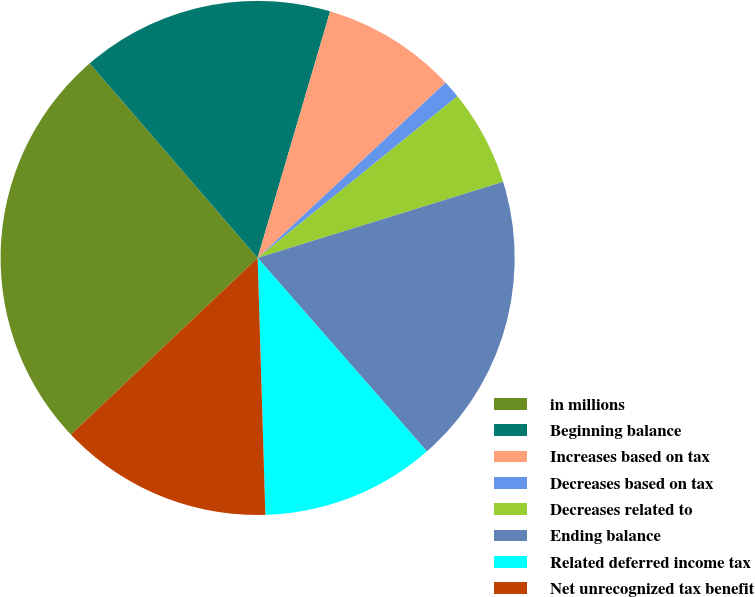Convert chart. <chart><loc_0><loc_0><loc_500><loc_500><pie_chart><fcel>in millions<fcel>Beginning balance<fcel>Increases based on tax<fcel>Decreases based on tax<fcel>Decreases related to<fcel>Ending balance<fcel>Related deferred income tax<fcel>Net unrecognized tax benefit<nl><fcel>25.72%<fcel>15.88%<fcel>8.5%<fcel>1.12%<fcel>6.04%<fcel>18.34%<fcel>10.96%<fcel>13.42%<nl></chart> 